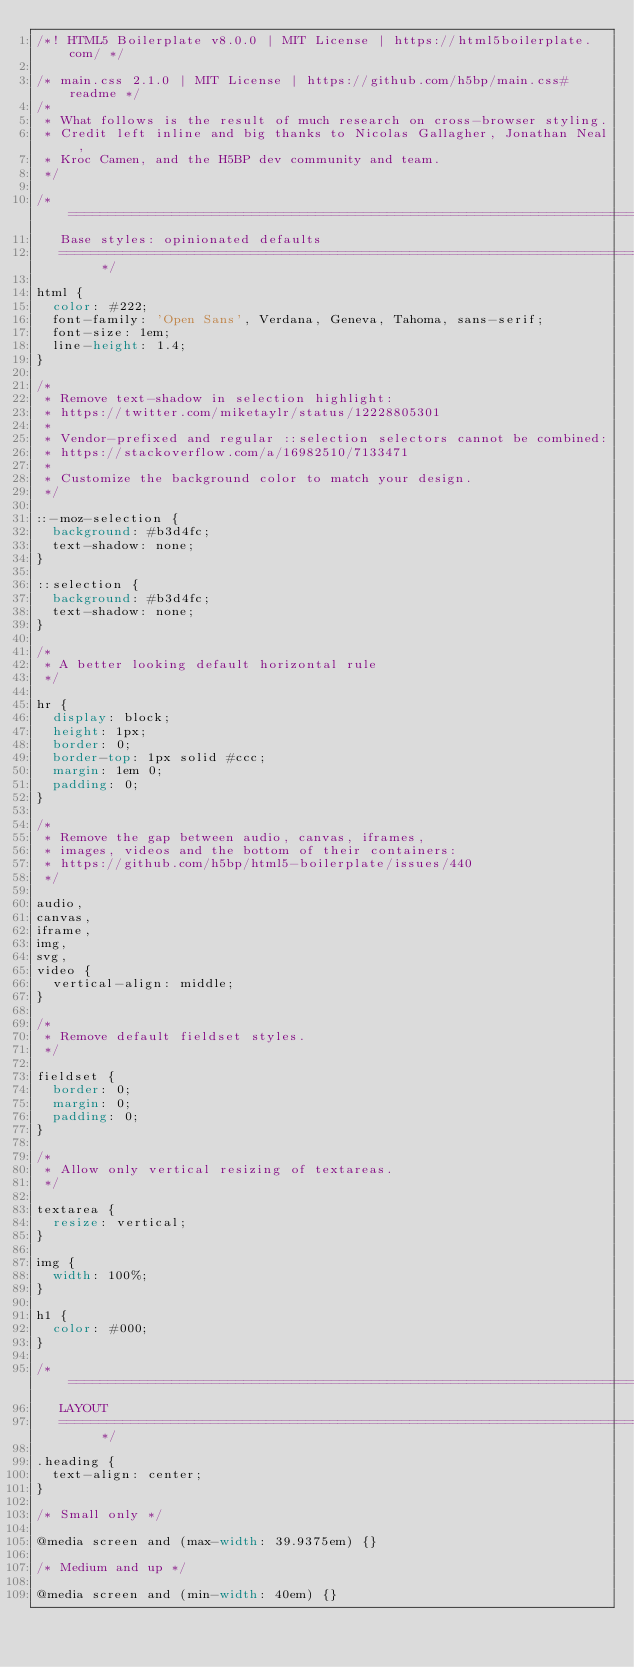Convert code to text. <code><loc_0><loc_0><loc_500><loc_500><_CSS_>/*! HTML5 Boilerplate v8.0.0 | MIT License | https://html5boilerplate.com/ */

/* main.css 2.1.0 | MIT License | https://github.com/h5bp/main.css#readme */
/*
 * What follows is the result of much research on cross-browser styling.
 * Credit left inline and big thanks to Nicolas Gallagher, Jonathan Neal,
 * Kroc Camen, and the H5BP dev community and team.
 */

/* ==========================================================================
   Base styles: opinionated defaults
   ========================================================================== */

html {
  color: #222;
  font-family: 'Open Sans', Verdana, Geneva, Tahoma, sans-serif;
  font-size: 1em;
  line-height: 1.4;
}

/*
 * Remove text-shadow in selection highlight:
 * https://twitter.com/miketaylr/status/12228805301
 *
 * Vendor-prefixed and regular ::selection selectors cannot be combined:
 * https://stackoverflow.com/a/16982510/7133471
 *
 * Customize the background color to match your design.
 */

::-moz-selection {
  background: #b3d4fc;
  text-shadow: none;
}

::selection {
  background: #b3d4fc;
  text-shadow: none;
}

/*
 * A better looking default horizontal rule
 */

hr {
  display: block;
  height: 1px;
  border: 0;
  border-top: 1px solid #ccc;
  margin: 1em 0;
  padding: 0;
}

/*
 * Remove the gap between audio, canvas, iframes,
 * images, videos and the bottom of their containers:
 * https://github.com/h5bp/html5-boilerplate/issues/440
 */

audio,
canvas,
iframe,
img,
svg,
video {
  vertical-align: middle;
}

/*
 * Remove default fieldset styles.
 */

fieldset {
  border: 0;
  margin: 0;
  padding: 0;
}

/*
 * Allow only vertical resizing of textareas.
 */

textarea {
  resize: vertical;
}

img {
  width: 100%;
}

h1 {
  color: #000;
}

/* ==========================================================================
   LAYOUT
   ========================================================================== */

.heading {
  text-align: center;
}

/* Small only */

@media screen and (max-width: 39.9375em) {}

/* Medium and up */

@media screen and (min-width: 40em) {}
</code> 